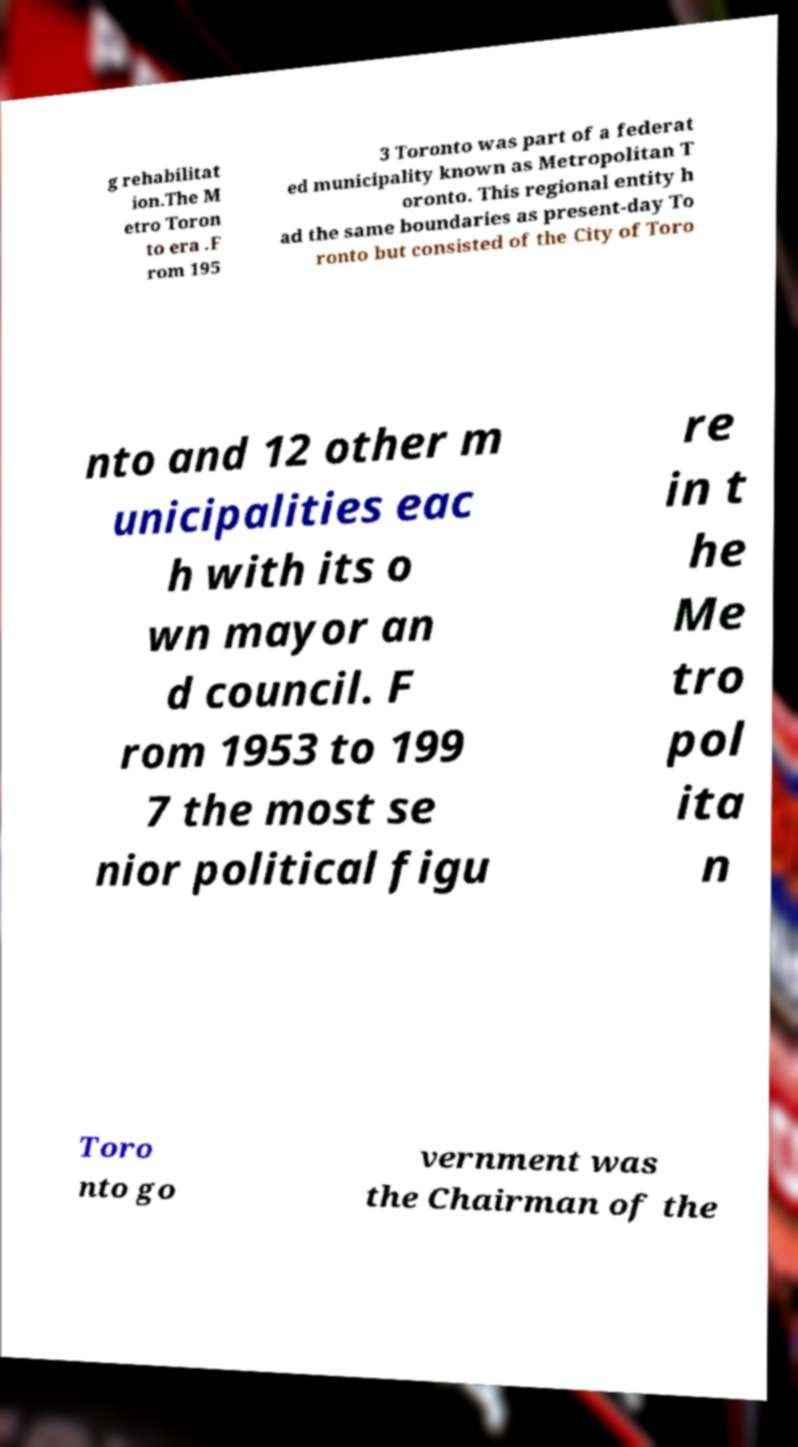Please read and relay the text visible in this image. What does it say? g rehabilitat ion.The M etro Toron to era .F rom 195 3 Toronto was part of a federat ed municipality known as Metropolitan T oronto. This regional entity h ad the same boundaries as present-day To ronto but consisted of the City of Toro nto and 12 other m unicipalities eac h with its o wn mayor an d council. F rom 1953 to 199 7 the most se nior political figu re in t he Me tro pol ita n Toro nto go vernment was the Chairman of the 